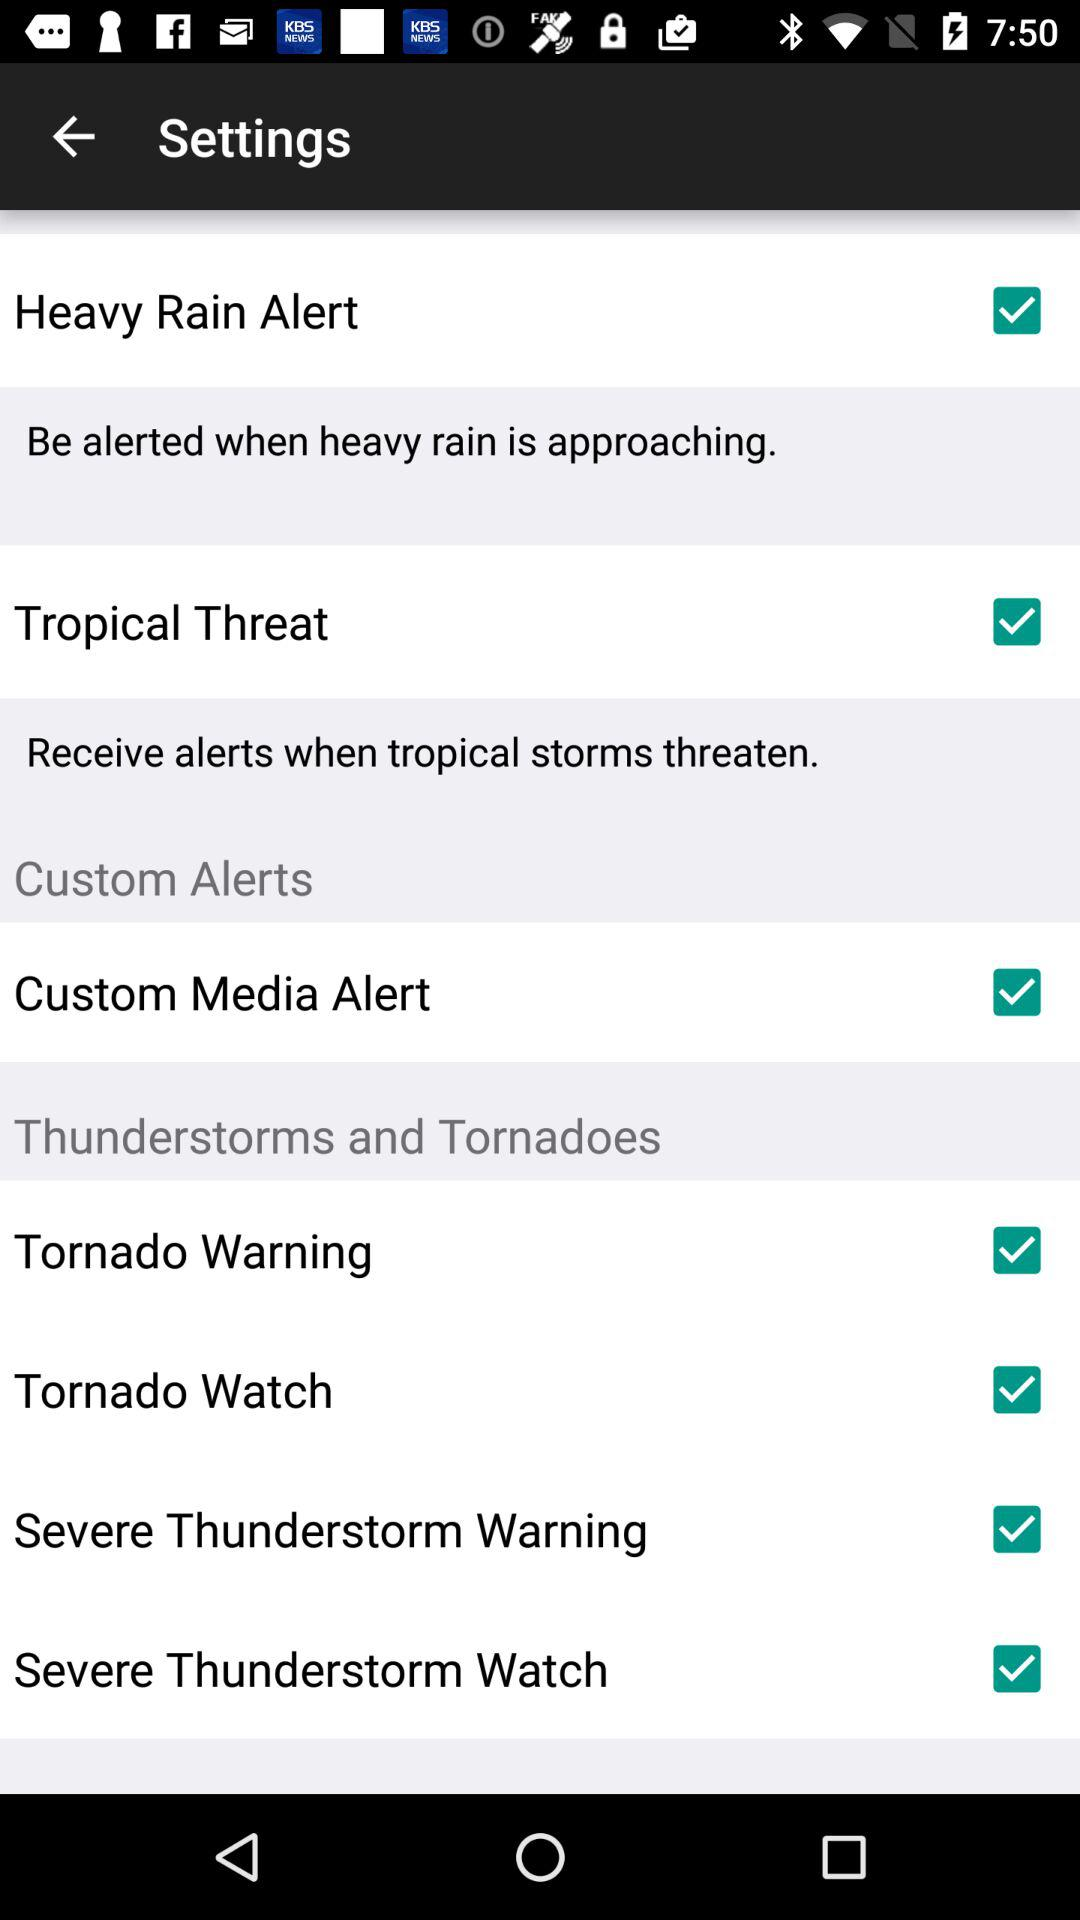What are the selected options? The selected options are "Heavy Rain Alert", "Tropical Threat", "Custom Media Alert", "Tornado Warning", "Tornado Watch", "Severe Thunderstorm Warning" and "Severe Thunderstorm Watch". 